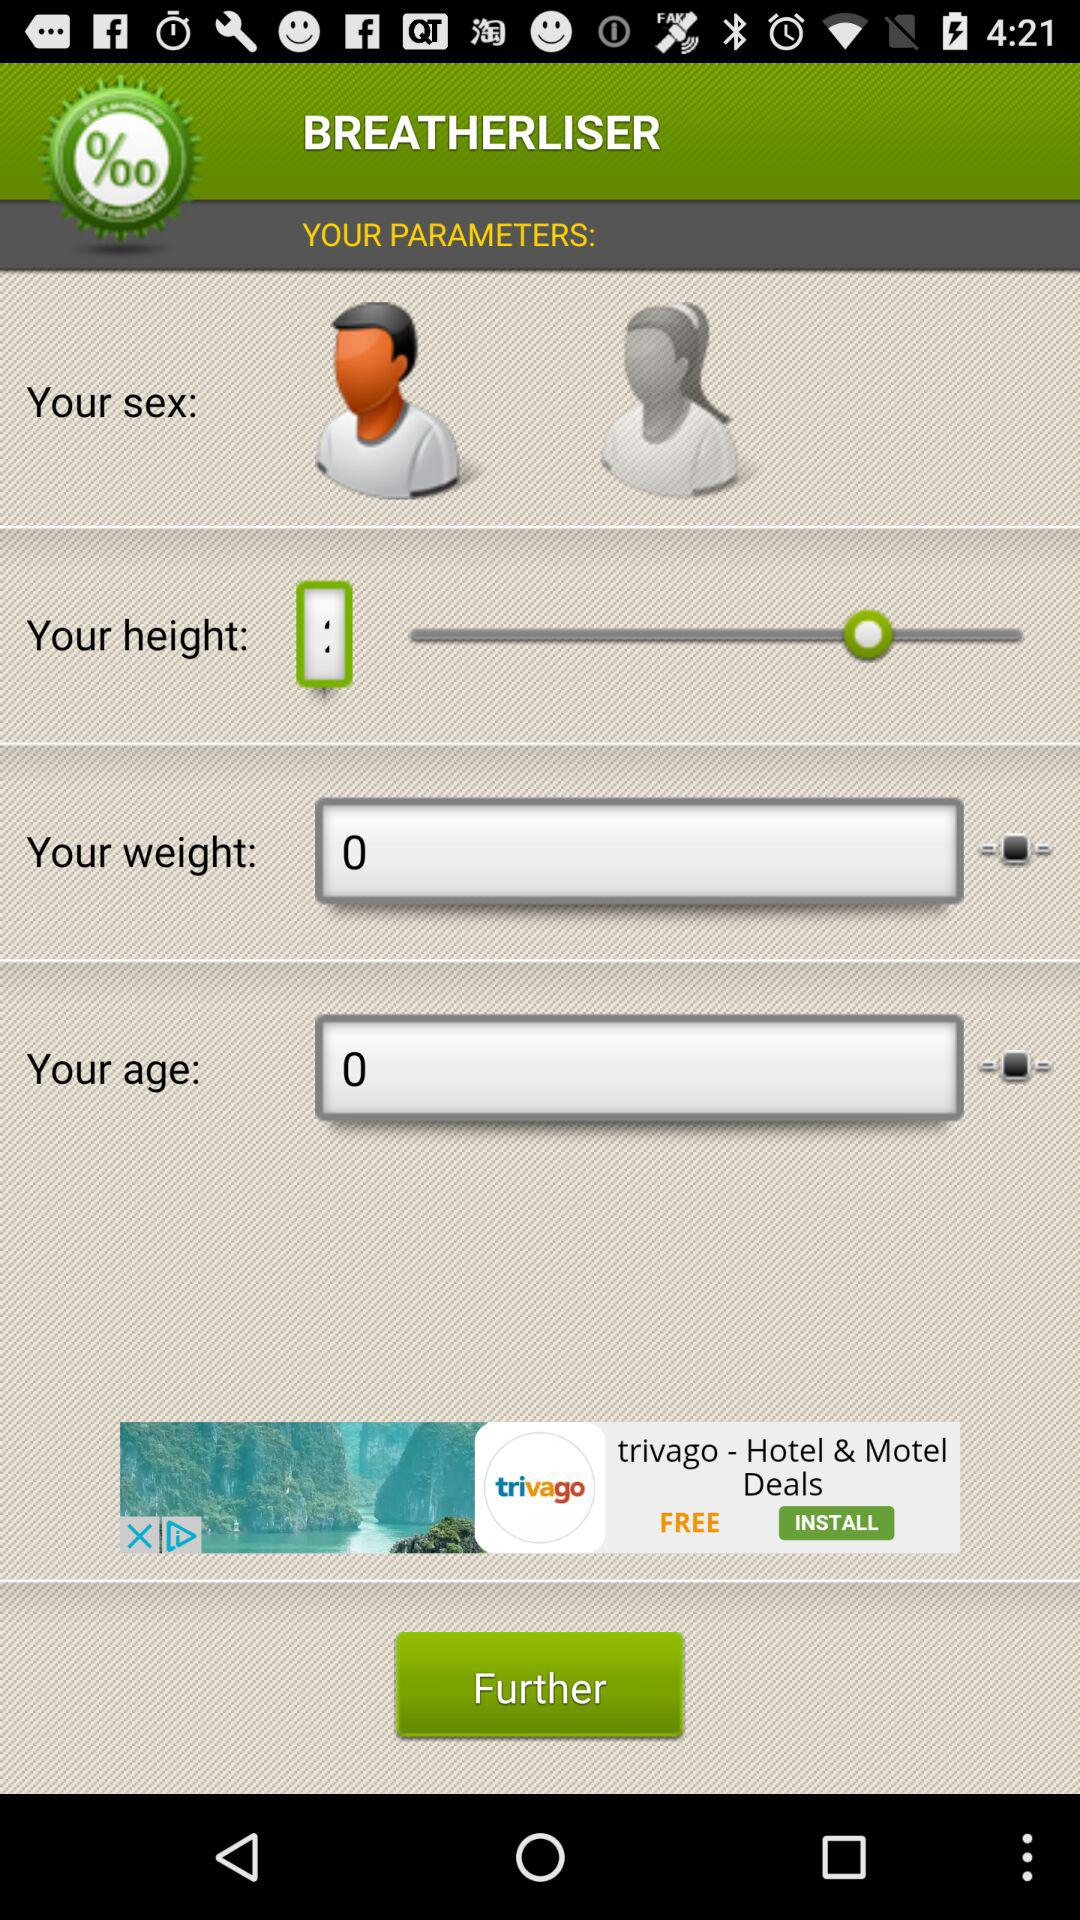What is the value of the input entered in the age bar? The value of the input entered in the age bar is 0. 